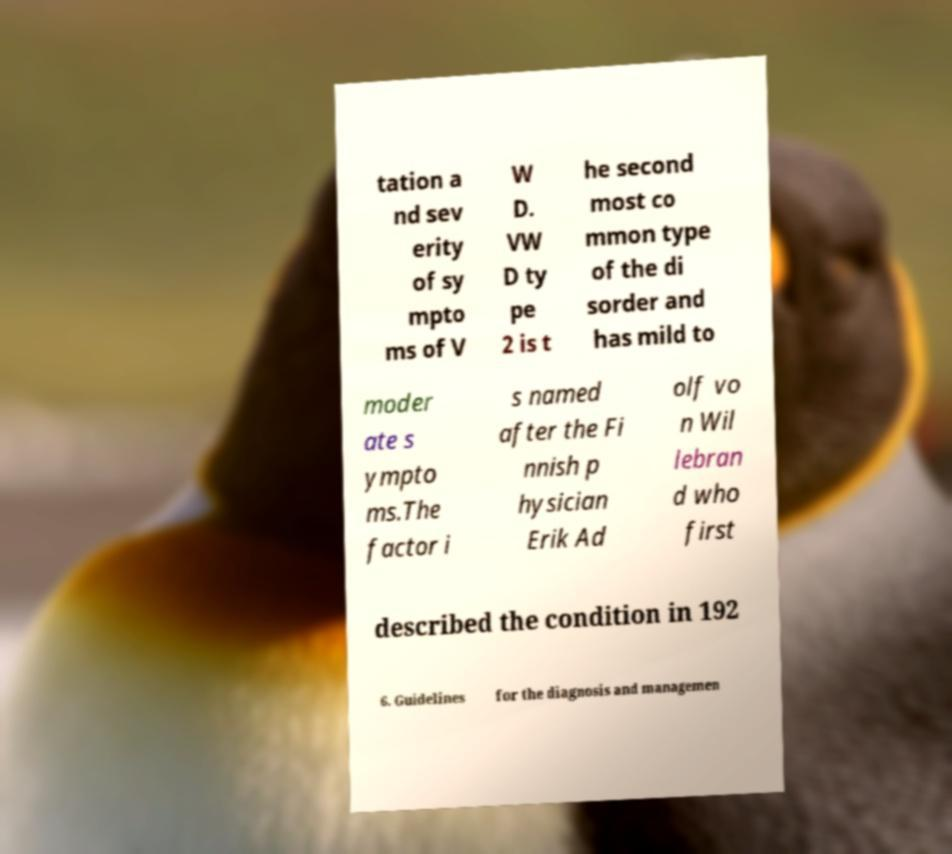Could you extract and type out the text from this image? tation a nd sev erity of sy mpto ms of V W D. VW D ty pe 2 is t he second most co mmon type of the di sorder and has mild to moder ate s ympto ms.The factor i s named after the Fi nnish p hysician Erik Ad olf vo n Wil lebran d who first described the condition in 192 6. Guidelines for the diagnosis and managemen 